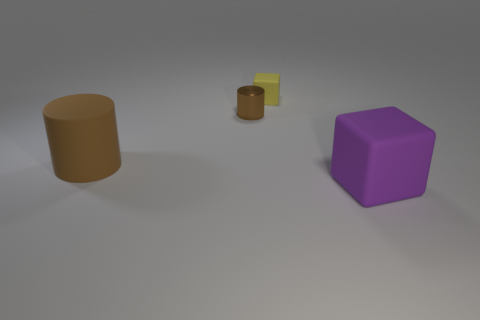Is the number of purple things greater than the number of cylinders?
Offer a very short reply. No. How big is the rubber object that is both behind the big purple matte object and in front of the small cylinder?
Keep it short and to the point. Large. There is another tiny cylinder that is the same color as the rubber cylinder; what material is it?
Your response must be concise. Metal. Are there the same number of big objects behind the yellow thing and tiny yellow matte things?
Make the answer very short. No. Is the size of the shiny cylinder the same as the brown matte thing?
Provide a short and direct response. No. What color is the object that is both to the left of the tiny yellow matte thing and behind the big cylinder?
Offer a terse response. Brown. The small object in front of the block that is behind the brown metal cylinder is made of what material?
Your answer should be compact. Metal. There is another brown object that is the same shape as the large brown object; what is its size?
Offer a terse response. Small. There is a cube that is on the left side of the purple matte thing; does it have the same color as the big matte block?
Offer a terse response. No. Is the number of small brown metallic cylinders less than the number of small cyan things?
Ensure brevity in your answer.  No. 